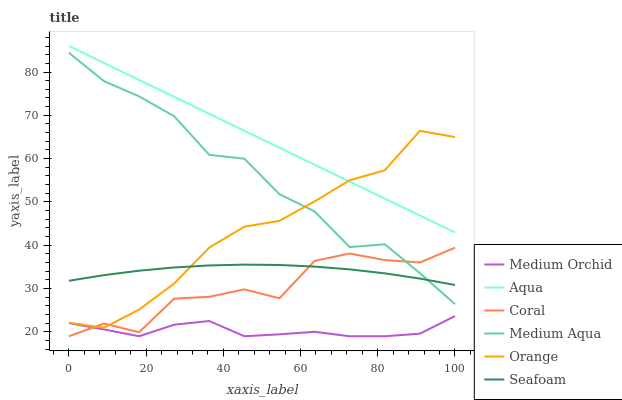Does Medium Orchid have the minimum area under the curve?
Answer yes or no. Yes. Does Aqua have the maximum area under the curve?
Answer yes or no. Yes. Does Aqua have the minimum area under the curve?
Answer yes or no. No. Does Medium Orchid have the maximum area under the curve?
Answer yes or no. No. Is Aqua the smoothest?
Answer yes or no. Yes. Is Coral the roughest?
Answer yes or no. Yes. Is Medium Orchid the smoothest?
Answer yes or no. No. Is Medium Orchid the roughest?
Answer yes or no. No. Does Aqua have the lowest value?
Answer yes or no. No. Does Aqua have the highest value?
Answer yes or no. Yes. Does Medium Orchid have the highest value?
Answer yes or no. No. Is Medium Orchid less than Orange?
Answer yes or no. Yes. Is Orange greater than Medium Orchid?
Answer yes or no. Yes. Does Coral intersect Medium Aqua?
Answer yes or no. Yes. Is Coral less than Medium Aqua?
Answer yes or no. No. Is Coral greater than Medium Aqua?
Answer yes or no. No. Does Medium Orchid intersect Orange?
Answer yes or no. No. 